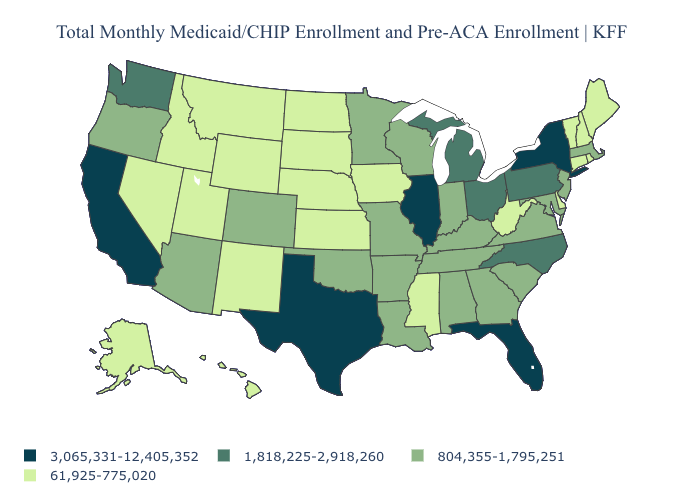Does Rhode Island have the highest value in the Northeast?
Short answer required. No. Name the states that have a value in the range 3,065,331-12,405,352?
Short answer required. California, Florida, Illinois, New York, Texas. What is the value of Montana?
Write a very short answer. 61,925-775,020. Which states hav the highest value in the West?
Concise answer only. California. How many symbols are there in the legend?
Give a very brief answer. 4. What is the lowest value in states that border Ohio?
Be succinct. 61,925-775,020. What is the highest value in states that border Connecticut?
Give a very brief answer. 3,065,331-12,405,352. Name the states that have a value in the range 61,925-775,020?
Keep it brief. Alaska, Connecticut, Delaware, Hawaii, Idaho, Iowa, Kansas, Maine, Mississippi, Montana, Nebraska, Nevada, New Hampshire, New Mexico, North Dakota, Rhode Island, South Dakota, Utah, Vermont, West Virginia, Wyoming. Name the states that have a value in the range 804,355-1,795,251?
Concise answer only. Alabama, Arizona, Arkansas, Colorado, Georgia, Indiana, Kentucky, Louisiana, Maryland, Massachusetts, Minnesota, Missouri, New Jersey, Oklahoma, Oregon, South Carolina, Tennessee, Virginia, Wisconsin. What is the value of Wisconsin?
Concise answer only. 804,355-1,795,251. What is the value of Hawaii?
Be succinct. 61,925-775,020. What is the value of North Dakota?
Give a very brief answer. 61,925-775,020. Which states have the highest value in the USA?
Quick response, please. California, Florida, Illinois, New York, Texas. Name the states that have a value in the range 3,065,331-12,405,352?
Keep it brief. California, Florida, Illinois, New York, Texas. How many symbols are there in the legend?
Be succinct. 4. 